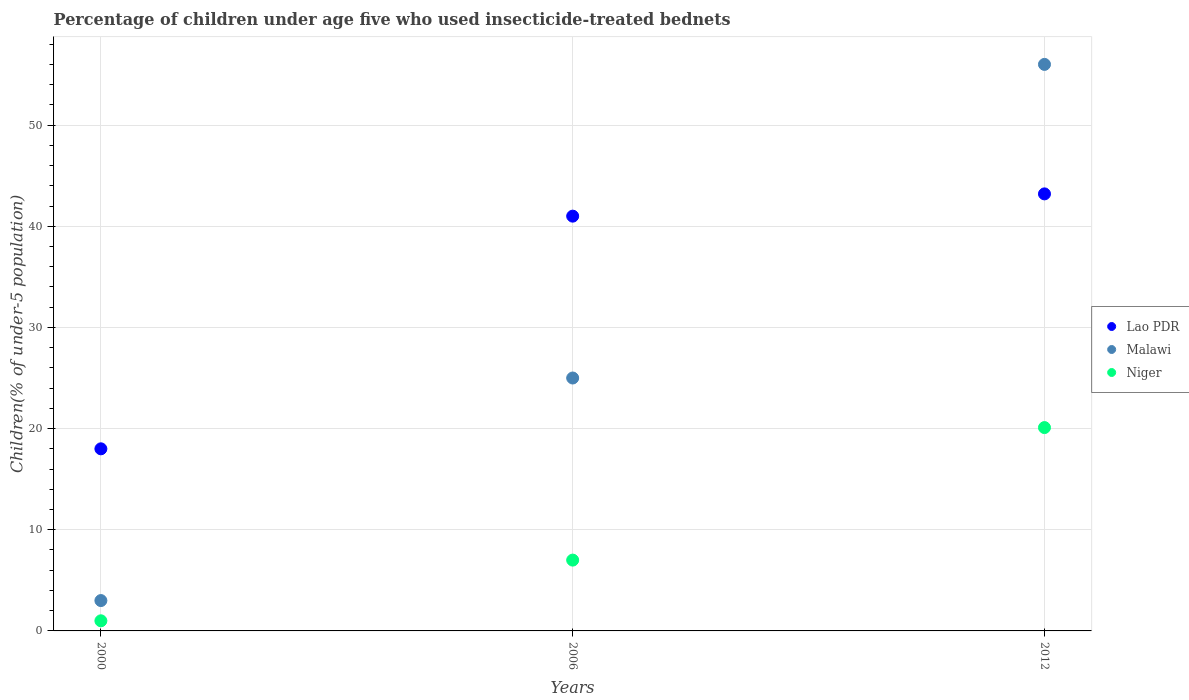Is the number of dotlines equal to the number of legend labels?
Give a very brief answer. Yes. What is the percentage of children under age five who used insecticide-treated bednets in Lao PDR in 2006?
Your response must be concise. 41. Across all years, what is the maximum percentage of children under age five who used insecticide-treated bednets in Lao PDR?
Your response must be concise. 43.2. In which year was the percentage of children under age five who used insecticide-treated bednets in Malawi maximum?
Your response must be concise. 2012. In which year was the percentage of children under age five who used insecticide-treated bednets in Malawi minimum?
Your response must be concise. 2000. What is the total percentage of children under age five who used insecticide-treated bednets in Malawi in the graph?
Ensure brevity in your answer.  84. What is the difference between the percentage of children under age five who used insecticide-treated bednets in Lao PDR in 2006 and that in 2012?
Provide a short and direct response. -2.2. What is the difference between the percentage of children under age five who used insecticide-treated bednets in Lao PDR in 2000 and the percentage of children under age five who used insecticide-treated bednets in Niger in 2012?
Keep it short and to the point. -2.1. What is the average percentage of children under age five who used insecticide-treated bednets in Lao PDR per year?
Your answer should be compact. 34.07. In the year 2012, what is the difference between the percentage of children under age five who used insecticide-treated bednets in Niger and percentage of children under age five who used insecticide-treated bednets in Lao PDR?
Ensure brevity in your answer.  -23.1. In how many years, is the percentage of children under age five who used insecticide-treated bednets in Niger greater than 12 %?
Provide a short and direct response. 1. What is the ratio of the percentage of children under age five who used insecticide-treated bednets in Niger in 2000 to that in 2012?
Ensure brevity in your answer.  0.05. Is the percentage of children under age five who used insecticide-treated bednets in Malawi in 2000 less than that in 2012?
Give a very brief answer. Yes. Is the difference between the percentage of children under age five who used insecticide-treated bednets in Niger in 2000 and 2012 greater than the difference between the percentage of children under age five who used insecticide-treated bednets in Lao PDR in 2000 and 2012?
Your answer should be compact. Yes. What is the difference between the highest and the second highest percentage of children under age five who used insecticide-treated bednets in Malawi?
Your answer should be very brief. 31. In how many years, is the percentage of children under age five who used insecticide-treated bednets in Lao PDR greater than the average percentage of children under age five who used insecticide-treated bednets in Lao PDR taken over all years?
Your answer should be very brief. 2. Is it the case that in every year, the sum of the percentage of children under age five who used insecticide-treated bednets in Malawi and percentage of children under age five who used insecticide-treated bednets in Niger  is greater than the percentage of children under age five who used insecticide-treated bednets in Lao PDR?
Make the answer very short. No. Does the percentage of children under age five who used insecticide-treated bednets in Malawi monotonically increase over the years?
Your answer should be compact. Yes. Is the percentage of children under age five who used insecticide-treated bednets in Niger strictly greater than the percentage of children under age five who used insecticide-treated bednets in Lao PDR over the years?
Make the answer very short. No. Is the percentage of children under age five who used insecticide-treated bednets in Lao PDR strictly less than the percentage of children under age five who used insecticide-treated bednets in Niger over the years?
Your answer should be compact. No. How many dotlines are there?
Offer a terse response. 3. Does the graph contain any zero values?
Give a very brief answer. No. Does the graph contain grids?
Give a very brief answer. Yes. What is the title of the graph?
Make the answer very short. Percentage of children under age five who used insecticide-treated bednets. What is the label or title of the Y-axis?
Provide a short and direct response. Children(% of under-5 population). What is the Children(% of under-5 population) of Niger in 2000?
Your response must be concise. 1. What is the Children(% of under-5 population) in Lao PDR in 2006?
Offer a very short reply. 41. What is the Children(% of under-5 population) of Malawi in 2006?
Keep it short and to the point. 25. What is the Children(% of under-5 population) of Lao PDR in 2012?
Make the answer very short. 43.2. What is the Children(% of under-5 population) in Malawi in 2012?
Your answer should be very brief. 56. What is the Children(% of under-5 population) of Niger in 2012?
Ensure brevity in your answer.  20.1. Across all years, what is the maximum Children(% of under-5 population) in Lao PDR?
Your answer should be very brief. 43.2. Across all years, what is the maximum Children(% of under-5 population) in Niger?
Give a very brief answer. 20.1. Across all years, what is the minimum Children(% of under-5 population) of Lao PDR?
Provide a short and direct response. 18. Across all years, what is the minimum Children(% of under-5 population) of Malawi?
Provide a succinct answer. 3. What is the total Children(% of under-5 population) in Lao PDR in the graph?
Give a very brief answer. 102.2. What is the total Children(% of under-5 population) in Niger in the graph?
Your answer should be very brief. 28.1. What is the difference between the Children(% of under-5 population) in Niger in 2000 and that in 2006?
Your answer should be compact. -6. What is the difference between the Children(% of under-5 population) in Lao PDR in 2000 and that in 2012?
Your answer should be very brief. -25.2. What is the difference between the Children(% of under-5 population) in Malawi in 2000 and that in 2012?
Provide a short and direct response. -53. What is the difference between the Children(% of under-5 population) of Niger in 2000 and that in 2012?
Your answer should be very brief. -19.1. What is the difference between the Children(% of under-5 population) in Malawi in 2006 and that in 2012?
Give a very brief answer. -31. What is the difference between the Children(% of under-5 population) in Lao PDR in 2000 and the Children(% of under-5 population) in Niger in 2006?
Your response must be concise. 11. What is the difference between the Children(% of under-5 population) of Malawi in 2000 and the Children(% of under-5 population) of Niger in 2006?
Your response must be concise. -4. What is the difference between the Children(% of under-5 population) in Lao PDR in 2000 and the Children(% of under-5 population) in Malawi in 2012?
Keep it short and to the point. -38. What is the difference between the Children(% of under-5 population) in Lao PDR in 2000 and the Children(% of under-5 population) in Niger in 2012?
Ensure brevity in your answer.  -2.1. What is the difference between the Children(% of under-5 population) of Malawi in 2000 and the Children(% of under-5 population) of Niger in 2012?
Offer a terse response. -17.1. What is the difference between the Children(% of under-5 population) of Lao PDR in 2006 and the Children(% of under-5 population) of Niger in 2012?
Your answer should be very brief. 20.9. What is the difference between the Children(% of under-5 population) of Malawi in 2006 and the Children(% of under-5 population) of Niger in 2012?
Make the answer very short. 4.9. What is the average Children(% of under-5 population) in Lao PDR per year?
Provide a succinct answer. 34.07. What is the average Children(% of under-5 population) of Malawi per year?
Your answer should be compact. 28. What is the average Children(% of under-5 population) of Niger per year?
Offer a very short reply. 9.37. In the year 2000, what is the difference between the Children(% of under-5 population) of Lao PDR and Children(% of under-5 population) of Malawi?
Ensure brevity in your answer.  15. In the year 2000, what is the difference between the Children(% of under-5 population) of Lao PDR and Children(% of under-5 population) of Niger?
Your answer should be very brief. 17. In the year 2006, what is the difference between the Children(% of under-5 population) of Malawi and Children(% of under-5 population) of Niger?
Offer a very short reply. 18. In the year 2012, what is the difference between the Children(% of under-5 population) in Lao PDR and Children(% of under-5 population) in Malawi?
Your response must be concise. -12.8. In the year 2012, what is the difference between the Children(% of under-5 population) in Lao PDR and Children(% of under-5 population) in Niger?
Offer a very short reply. 23.1. In the year 2012, what is the difference between the Children(% of under-5 population) of Malawi and Children(% of under-5 population) of Niger?
Ensure brevity in your answer.  35.9. What is the ratio of the Children(% of under-5 population) of Lao PDR in 2000 to that in 2006?
Your answer should be very brief. 0.44. What is the ratio of the Children(% of under-5 population) of Malawi in 2000 to that in 2006?
Your response must be concise. 0.12. What is the ratio of the Children(% of under-5 population) in Niger in 2000 to that in 2006?
Your response must be concise. 0.14. What is the ratio of the Children(% of under-5 population) of Lao PDR in 2000 to that in 2012?
Keep it short and to the point. 0.42. What is the ratio of the Children(% of under-5 population) in Malawi in 2000 to that in 2012?
Your answer should be very brief. 0.05. What is the ratio of the Children(% of under-5 population) of Niger in 2000 to that in 2012?
Offer a terse response. 0.05. What is the ratio of the Children(% of under-5 population) of Lao PDR in 2006 to that in 2012?
Keep it short and to the point. 0.95. What is the ratio of the Children(% of under-5 population) of Malawi in 2006 to that in 2012?
Give a very brief answer. 0.45. What is the ratio of the Children(% of under-5 population) in Niger in 2006 to that in 2012?
Provide a succinct answer. 0.35. What is the difference between the highest and the second highest Children(% of under-5 population) in Lao PDR?
Provide a short and direct response. 2.2. What is the difference between the highest and the second highest Children(% of under-5 population) in Niger?
Ensure brevity in your answer.  13.1. What is the difference between the highest and the lowest Children(% of under-5 population) in Lao PDR?
Your answer should be very brief. 25.2. What is the difference between the highest and the lowest Children(% of under-5 population) of Niger?
Keep it short and to the point. 19.1. 